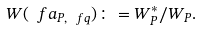Convert formula to latex. <formula><loc_0><loc_0><loc_500><loc_500>W ( \ f a _ { P , \ f q } ) \colon = W _ { P } ^ { * } / W _ { P } .</formula> 